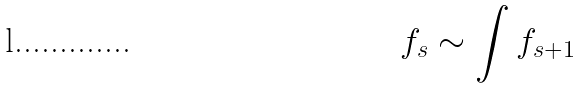<formula> <loc_0><loc_0><loc_500><loc_500>f _ { s } \sim \int f _ { s + 1 }</formula> 